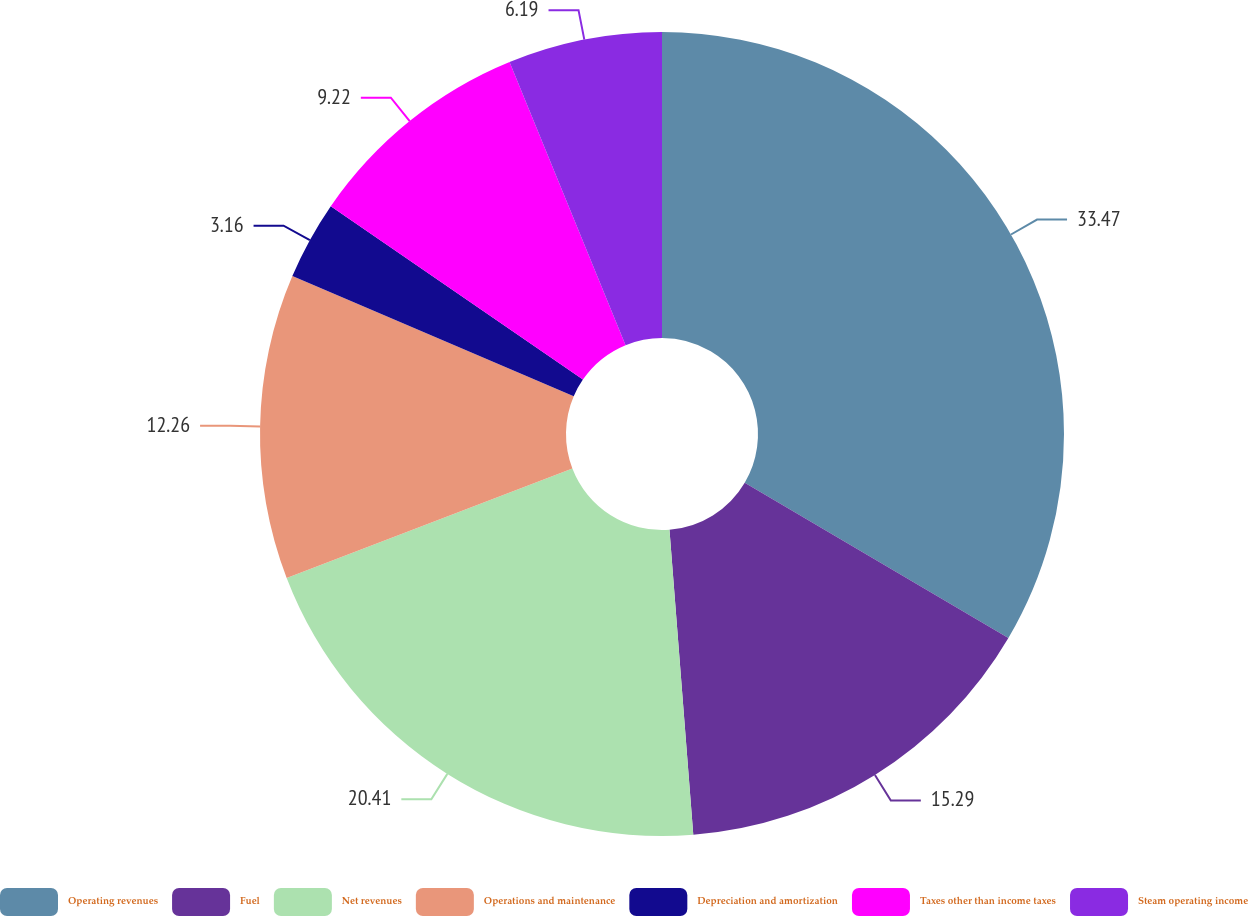<chart> <loc_0><loc_0><loc_500><loc_500><pie_chart><fcel>Operating revenues<fcel>Fuel<fcel>Net revenues<fcel>Operations and maintenance<fcel>Depreciation and amortization<fcel>Taxes other than income taxes<fcel>Steam operating income<nl><fcel>33.47%<fcel>15.29%<fcel>20.41%<fcel>12.26%<fcel>3.16%<fcel>9.22%<fcel>6.19%<nl></chart> 